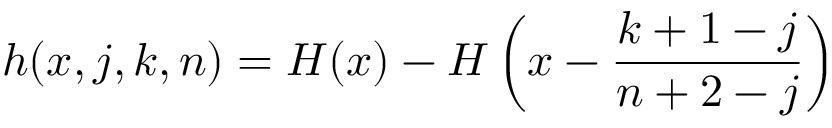Convert formula to latex. <formula><loc_0><loc_0><loc_500><loc_500>h ( x , j , k , n ) = H ( x ) - H \left ( x - \frac { k + 1 - j } { n + 2 - j } \right )</formula> 